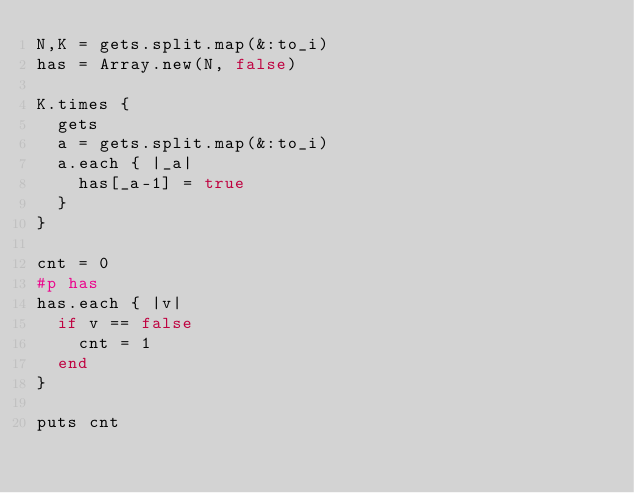<code> <loc_0><loc_0><loc_500><loc_500><_Ruby_>N,K = gets.split.map(&:to_i)
has = Array.new(N, false)
 
K.times {
  gets
  a = gets.split.map(&:to_i)
  a.each { |_a|
    has[_a-1] = true
  }
}
 
cnt = 0
#p has
has.each { |v|
  if v == false
    cnt = 1
  end
}
 
puts cnt</code> 